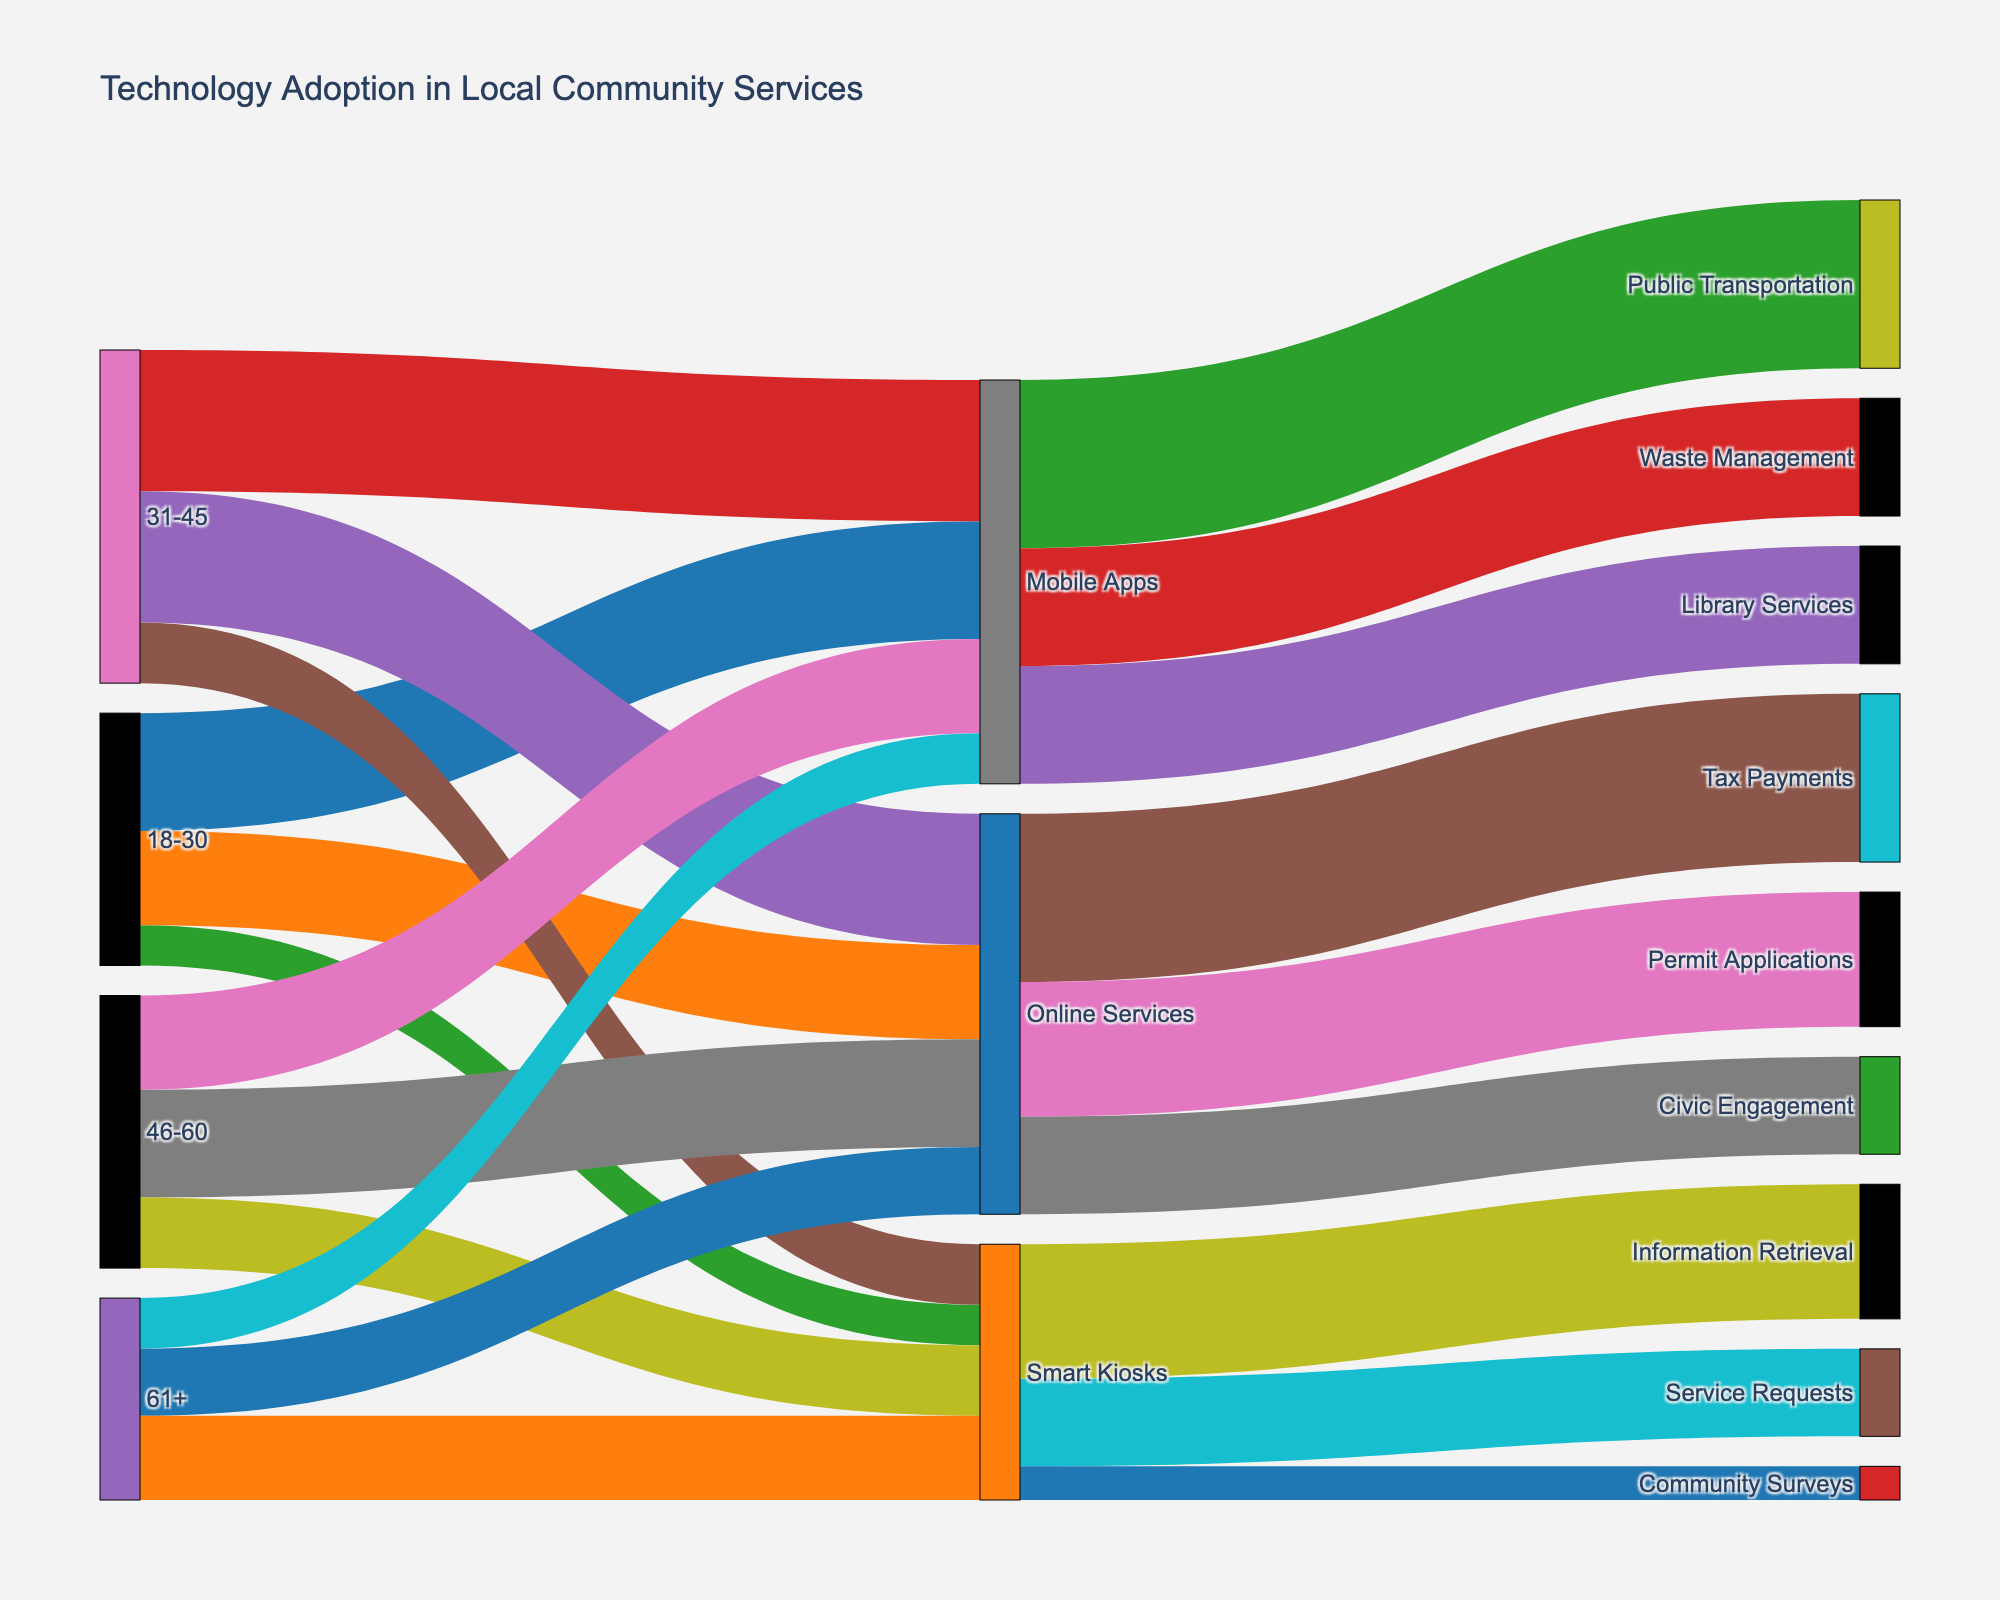Is there a title for this figure? The title of a figure is typically displayed at the top and provides an overview of the content or purpose of the visualization. In this case, the title is "Technology Adoption in Local Community Services."
Answer: Technology Adoption in Local Community Services Which technology has the highest adoption among the age group 31-45? To identify the highest adoption, we look at the connections from age group 31-45. Mobile Apps show a value of 4200, which is the highest among Smart Kiosks (1800) and Online Services (3900). Therefore, the highest adoption is Mobile Apps.
Answer: Mobile Apps What's the total number of users in the 46-60 age group across all technologies? Adding the values for Mobile Apps (2800), Online Services (3200), and Smart Kiosks (2100) in the 46-60 age group, we get the total number of users: 2800 + 3200 + 2100 = 8100.
Answer: 8100 Which age group uses Smart Kiosks the least? By comparing the values for Smart Kiosks across the age groups: 18-30 (1200), 31-45 (1800), 46-60 (2100), and 61+ (2500), it's clear that the age group 18-30 has the lowest value at 1200.
Answer: 18-30 How does the use of Mobile Apps for Public Transportation compare to Library Services? The Sankey diagram shows Mobile Apps connecting to Public Transportation with a value of 5000 and to Library Services with a value of 3500. The use of Mobile Apps for Public Transportation is higher than for Library Services.
Answer: Public Transportation is higher Between Online Services and Smart Kiosks which category has more users for Civic Engagement and Community Surveys respectively? Online Services for Civic Engagement has 2900 users, while Smart Kiosks for Community Surveys has 1000 users. Thus, Online Services have more users for these specific activities.
Answer: Online Services What's the most popular method for Permit Applications? The connections for Permit Applications link to Online Services with a value of 4000. This suggests Online Services is the most popular method for Permit Applications.
Answer: Online Services Which service receives the highest number of users through Smart Kiosks? Among Smart Kiosks' connections, Information Retrieval has the highest value at 4000 users.
Answer: Information Retrieval Compare the total number of users utilizing Mobile Apps versus Online Services. Summing the values for Mobile Apps (3500, 4200, 2800, 1500) gives a total of 12000. For Online Services (2800, 3900, 3200, 2000), the total is 11900. Mobile Apps have slightly more users than Online Services.
Answer: Mobile Apps have more What is the least used service out of those listed? By examining the target values, the connection to Community Surveys via Smart Kiosks has the lowest value at 1000.
Answer: Community Surveys 